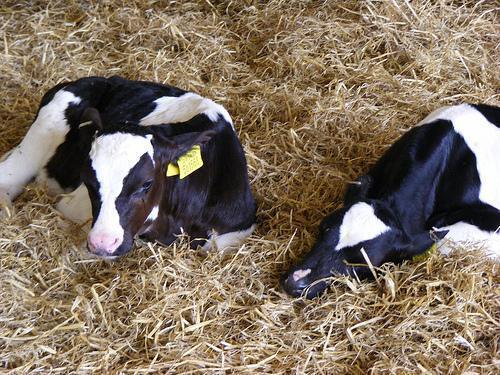How many eyes can be seen?
Give a very brief answer. 1. 